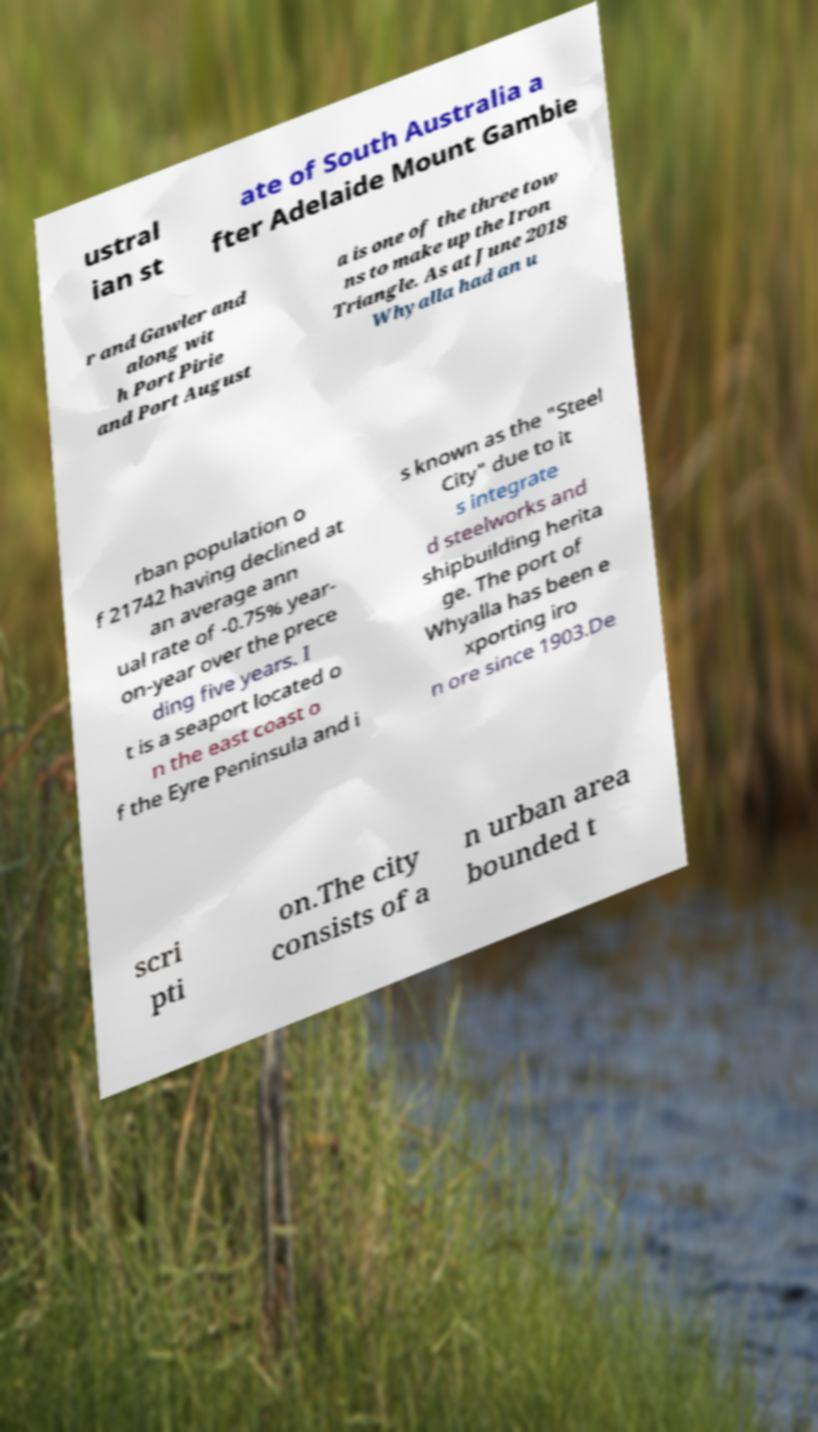Please identify and transcribe the text found in this image. ustral ian st ate of South Australia a fter Adelaide Mount Gambie r and Gawler and along wit h Port Pirie and Port August a is one of the three tow ns to make up the Iron Triangle. As at June 2018 Whyalla had an u rban population o f 21742 having declined at an average ann ual rate of -0.75% year- on-year over the prece ding five years. I t is a seaport located o n the east coast o f the Eyre Peninsula and i s known as the "Steel City" due to it s integrate d steelworks and shipbuilding herita ge. The port of Whyalla has been e xporting iro n ore since 1903.De scri pti on.The city consists of a n urban area bounded t 